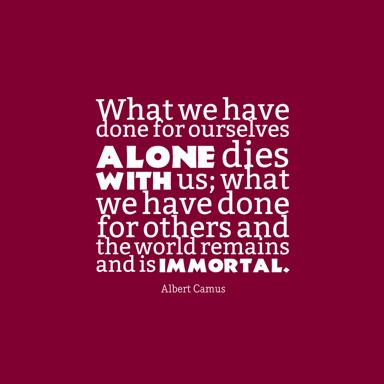What does the color scheme represent in this image? The bold red background paired with the stark white text in this image not only draws immediate visual attention but also symbolically underscores the profoundness of Camus' words. Red, often associated with passion and intensity, serves to engage the viewer's emotions, making the message more impactful. The contrasting white, representing purity and clarity, further highlights the immortal nature of altruistic deeds, as described by Camus. This color choice could be seen as an artistic representation of the quote's theme: vivid, passionate life actions that leave a clear, enduring legacy. 